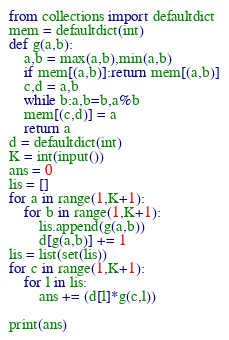<code> <loc_0><loc_0><loc_500><loc_500><_Python_>from collections import defaultdict
mem = defaultdict(int)
def g(a,b):
    a,b = max(a,b),min(a,b)
    if mem[(a,b)]:return mem[(a,b)]
    c,d = a,b
    while b:a,b=b,a%b
    mem[(c,d)] = a
    return a
d = defaultdict(int)
K = int(input())
ans = 0
lis = []
for a in range(1,K+1):
    for b in range(1,K+1):
        lis.append(g(a,b))
        d[g(a,b)] += 1
lis = list(set(lis))
for c in range(1,K+1):
    for l in lis:
        ans += (d[l]*g(c,l))

print(ans)</code> 